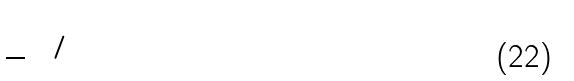Convert formula to latex. <formula><loc_0><loc_0><loc_500><loc_500>( \frac { 7 } { 3 } ) ^ { 6 / 1 0 }</formula> 